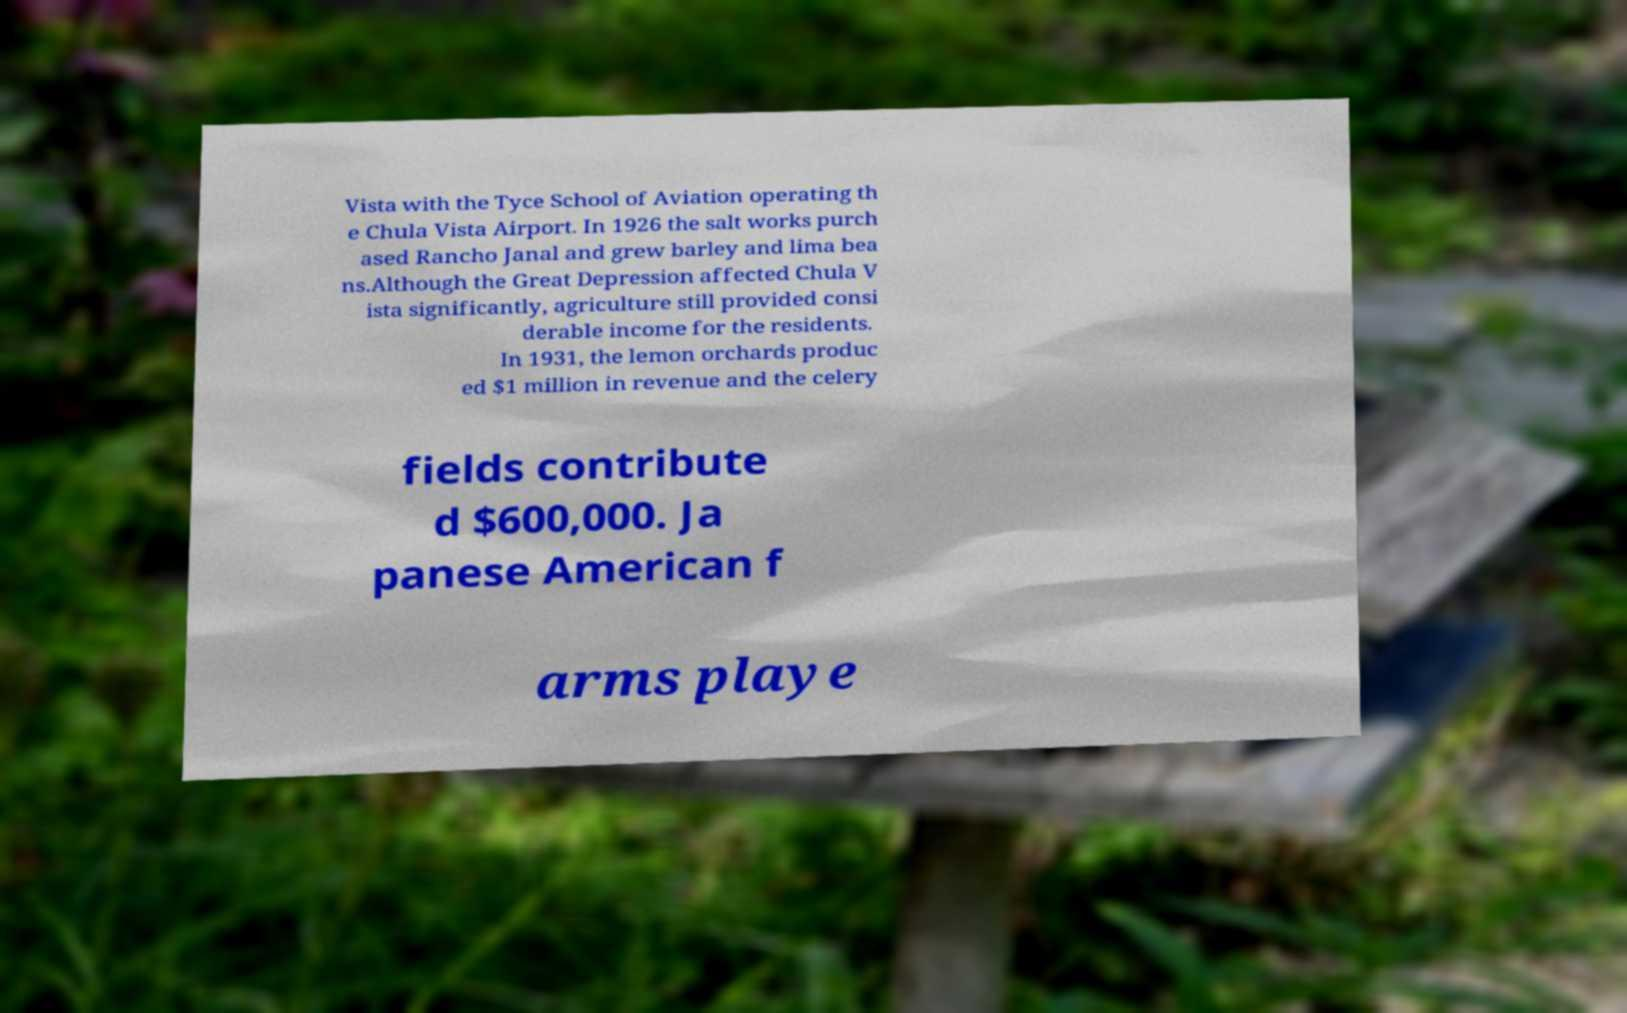Please read and relay the text visible in this image. What does it say? Vista with the Tyce School of Aviation operating th e Chula Vista Airport. In 1926 the salt works purch ased Rancho Janal and grew barley and lima bea ns.Although the Great Depression affected Chula V ista significantly, agriculture still provided consi derable income for the residents. In 1931, the lemon orchards produc ed $1 million in revenue and the celery fields contribute d $600,000. Ja panese American f arms playe 